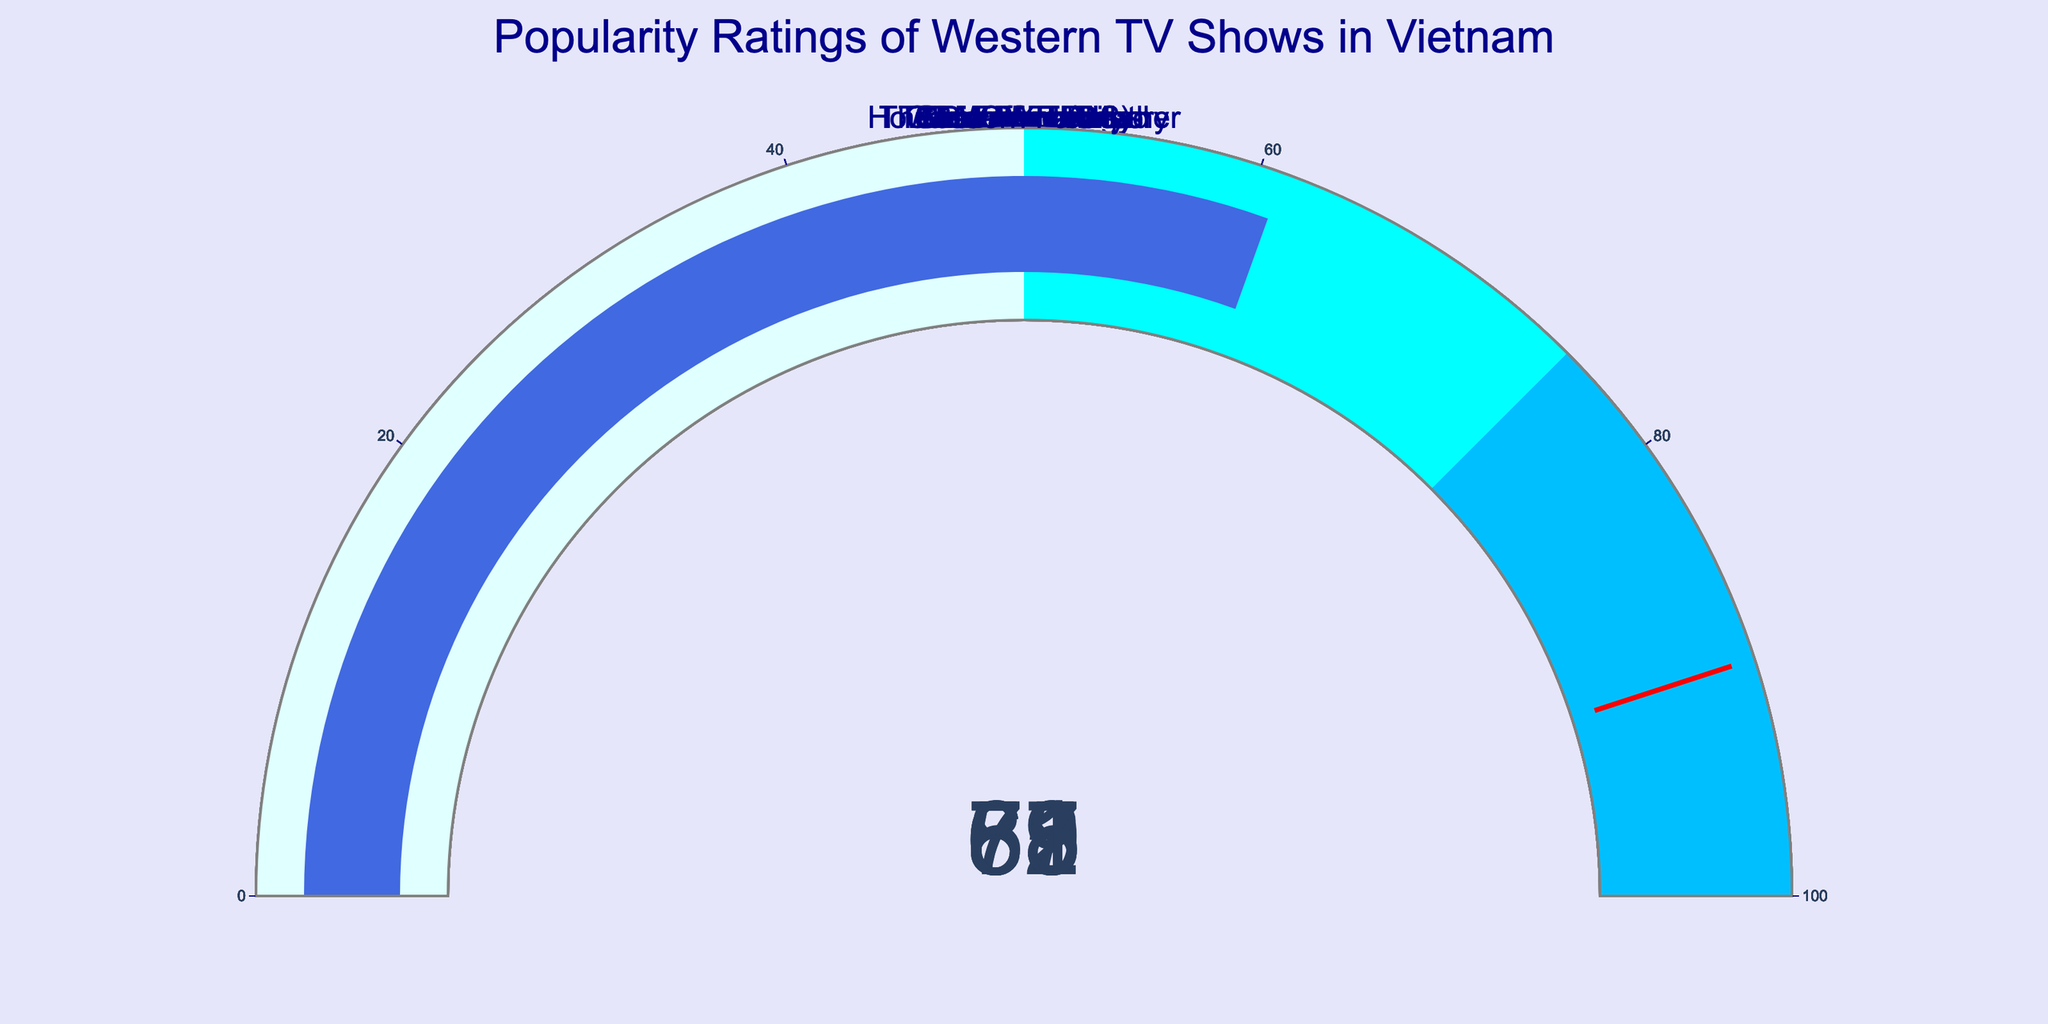What is the highest popularity rating among the shows? The highest popularity rating can be identified by looking at the gauges and finding the one with the highest displayed value. "Game of Thrones" has a popularity rating of 85.
Answer: 85 Which show has the lowest popularity rating? To identify the show with the lowest popularity rating, observe the gauges and locate the one with the smallest value. "Grey's Anatomy" has the lowest rating at 55.
Answer: Grey's Anatomy How many shows have a popularity rating above 75? Count the number of gauges that show a popularity rating greater than 75. The shows "Friends," "Stranger Things," and "Game of Thrones" have ratings of 78, 81, and 85 respectively.
Answer: 3 What is the average popularity rating of all shows? Add all the popularity ratings together (78+85+72+81+69+63+58+55+67+61) and then divide by the total number of shows (10). The sum is 689, so the average is 689/10 = 68.9.
Answer: 68.9 Which show has a rating just above "The Big Bang Theory"? First, find the rating of "The Big Bang Theory," which is 69. Then, look for the next higher rating, which is 72 for "Breaking Bad."
Answer: Breaking Bad Is the popularity rating for "Friends" greater than "Stranger Things"? Compare the ratings of "Friends" (78) and "Stranger Things" (81). "Stranger Things" has a higher rating.
Answer: No What is the sum of the ratings for "The Office (US)" and "Modern Family"? Add the ratings for "The Office (US)" (67) and "Modern Family" (61). The total is 67 + 61 = 128.
Answer: 128 Which show has a lower popularity rating: "How I Met Your Mother" or "The Walking Dead"? Compare the ratings of "How I Met Your Mother" (63) and "The Walking Dead" (58). "The Walking Dead" has a lower rating.
Answer: The Walking Dead What is the range of popularity ratings across all shows? Find the difference between the highest rating (85) and the lowest rating (55). The range is 85 - 55 = 30.
Answer: 30 Which rating threshold is closest to "Grey's Anatomy"? Determine the proximity of "Grey's Anatomy" rating (55) to the defined thresholds (50, 75, 90). It is closest to the threshold of 50.
Answer: 50 